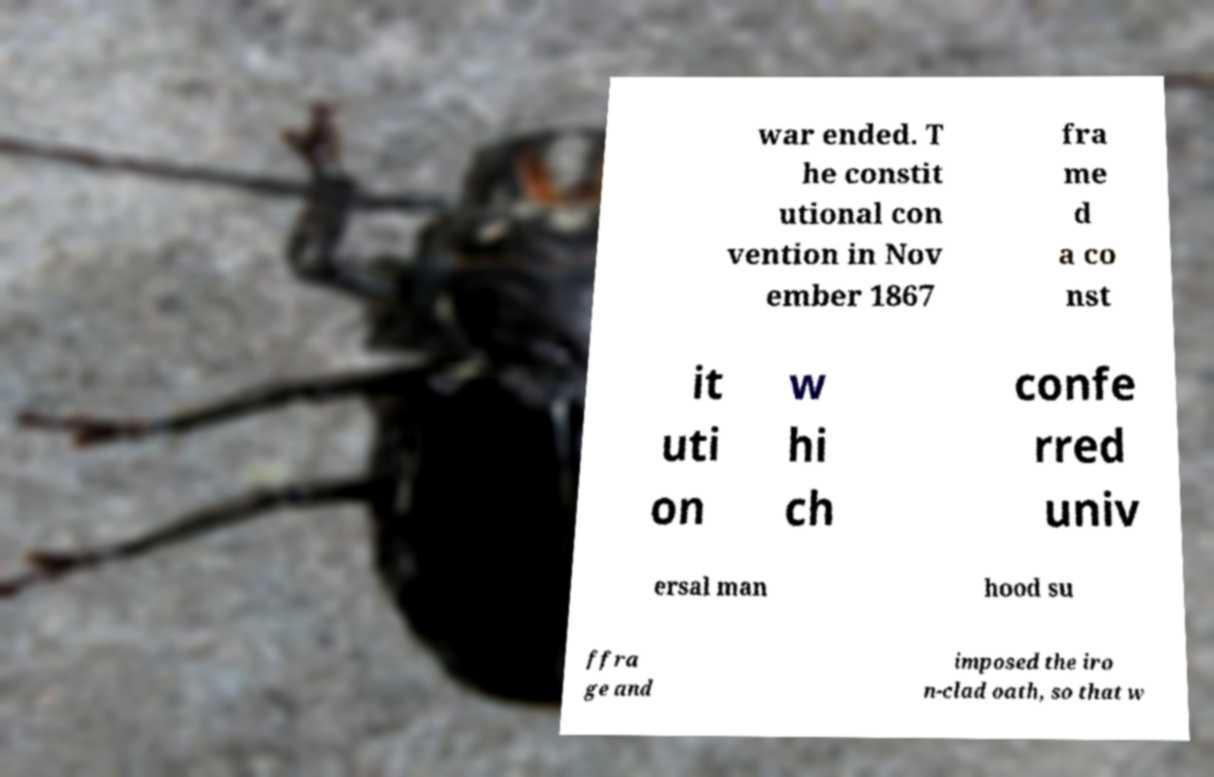Can you accurately transcribe the text from the provided image for me? war ended. T he constit utional con vention in Nov ember 1867 fra me d a co nst it uti on w hi ch confe rred univ ersal man hood su ffra ge and imposed the iro n-clad oath, so that w 